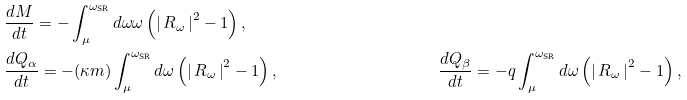Convert formula to latex. <formula><loc_0><loc_0><loc_500><loc_500>& \frac { d M } { d t } = - \int ^ { \omega _ { \text {SR} } } _ { \mu } d \omega \omega \left ( \left | \, R _ { \omega } \, \right | ^ { 2 } - 1 \right ) , \\ & \frac { d Q _ { \alpha } } { d t } = - ( \kappa m ) \int ^ { \omega _ { \text {SR} } } _ { \mu } d \omega \left ( \left | \, R _ { \omega } \, \right | ^ { 2 } - 1 \right ) , & & \frac { d Q _ { \beta } } { d t } = - q \int ^ { \omega _ { \text {SR} } } _ { \mu } d \omega \left ( \left | \, R _ { \omega } \, \right | ^ { 2 } - 1 \right ) ,</formula> 